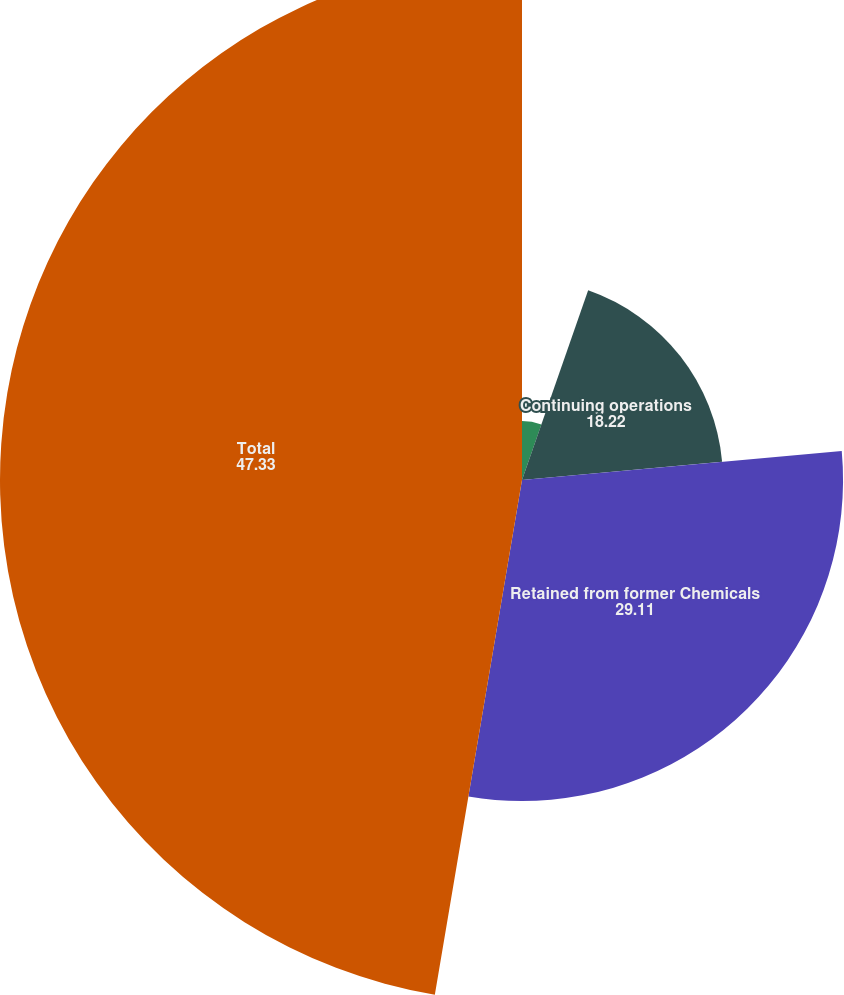Convert chart. <chart><loc_0><loc_0><loc_500><loc_500><pie_chart><fcel>in thousands<fcel>Continuing operations<fcel>Retained from former Chemicals<fcel>Total<nl><fcel>5.34%<fcel>18.22%<fcel>29.11%<fcel>47.33%<nl></chart> 